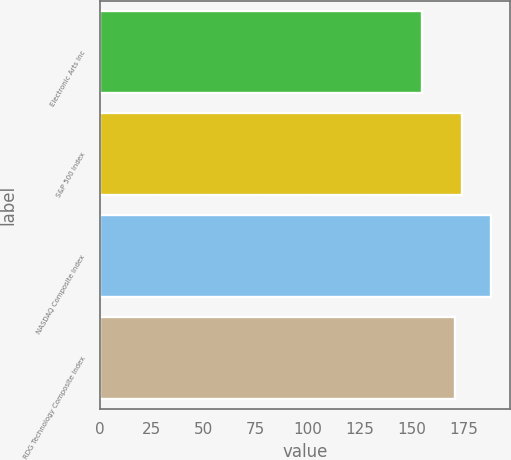<chart> <loc_0><loc_0><loc_500><loc_500><bar_chart><fcel>Electronic Arts Inc<fcel>S&P 500 Index<fcel>NASDAQ Composite Index<fcel>RDG Technology Composite Index<nl><fcel>155<fcel>174.3<fcel>188<fcel>171<nl></chart> 